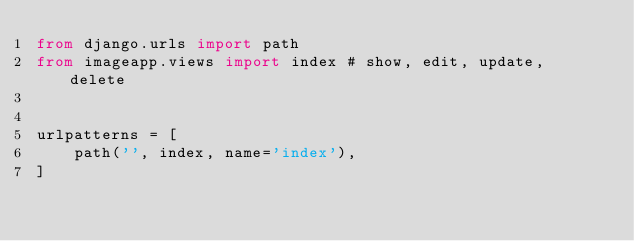Convert code to text. <code><loc_0><loc_0><loc_500><loc_500><_Python_>from django.urls import path
from imageapp.views import index # show, edit, update, delete


urlpatterns = [
    path('', index, name='index'),
]</code> 